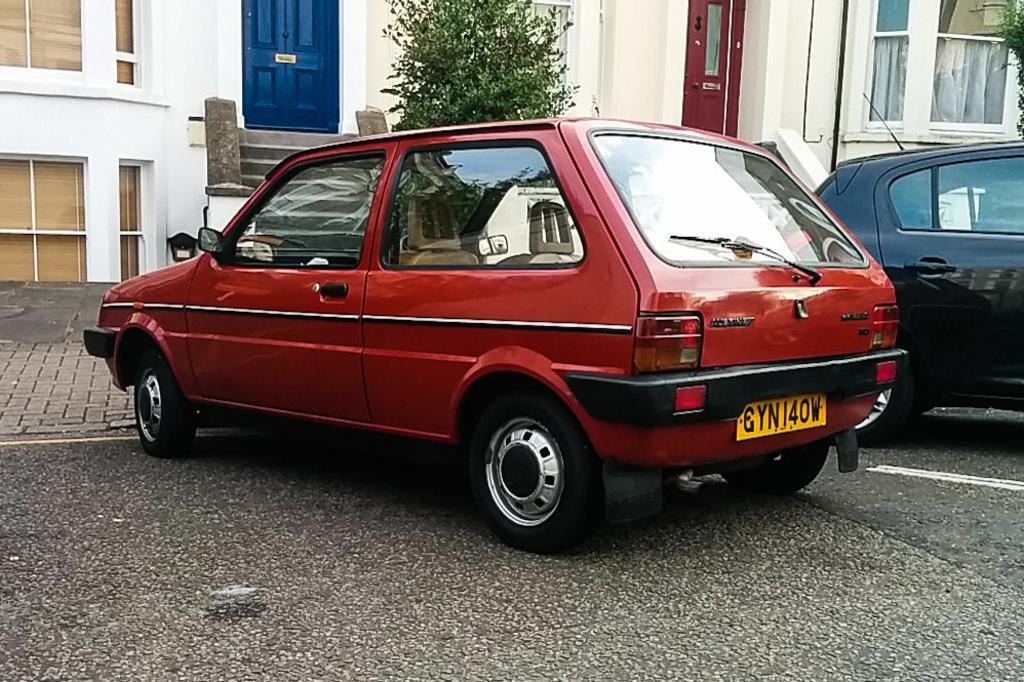In one or two sentences, can you explain what this image depicts? In this image I see 2 cars which are of red and black in color and I see the number plate over here on which there are numbers and alphabets written and I see the road. In the background I see the buildings and I see the trees. 